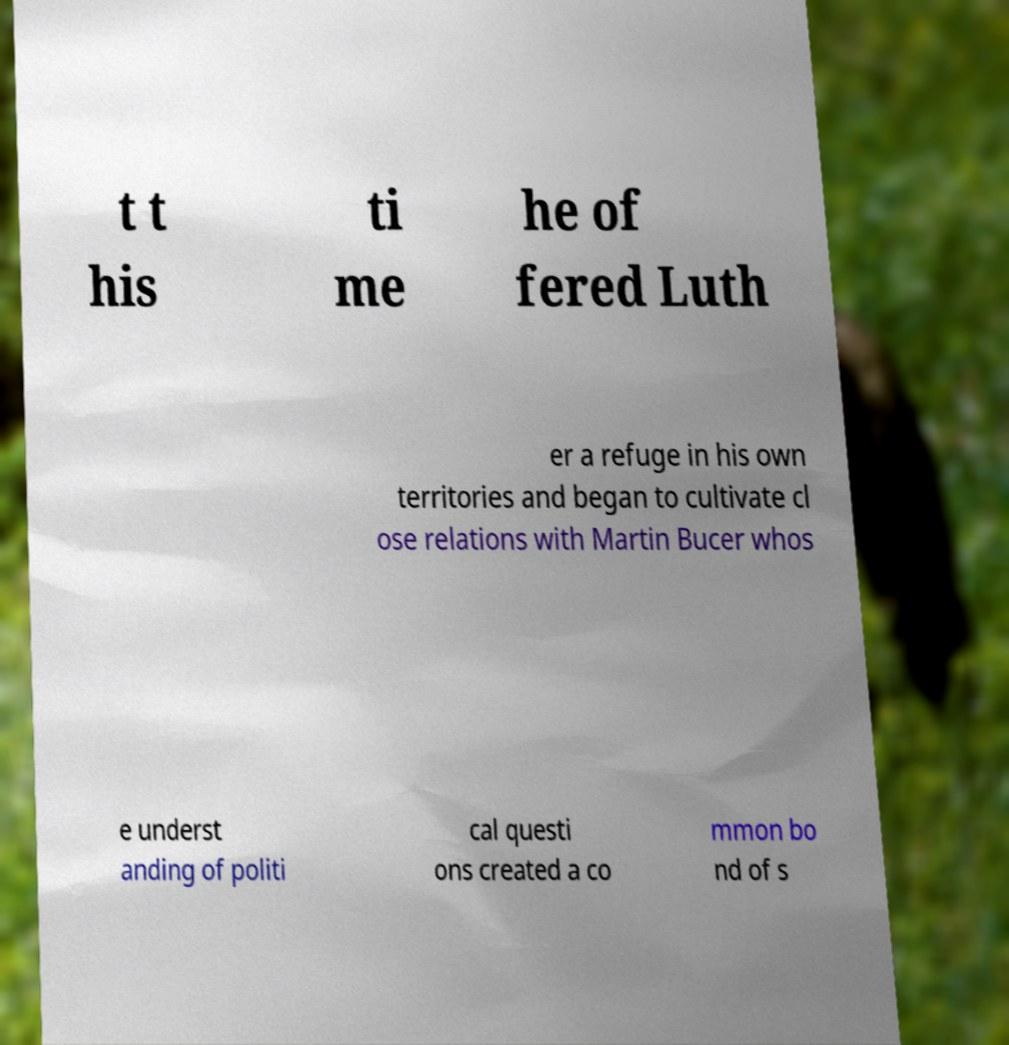I need the written content from this picture converted into text. Can you do that? t t his ti me he of fered Luth er a refuge in his own territories and began to cultivate cl ose relations with Martin Bucer whos e underst anding of politi cal questi ons created a co mmon bo nd of s 